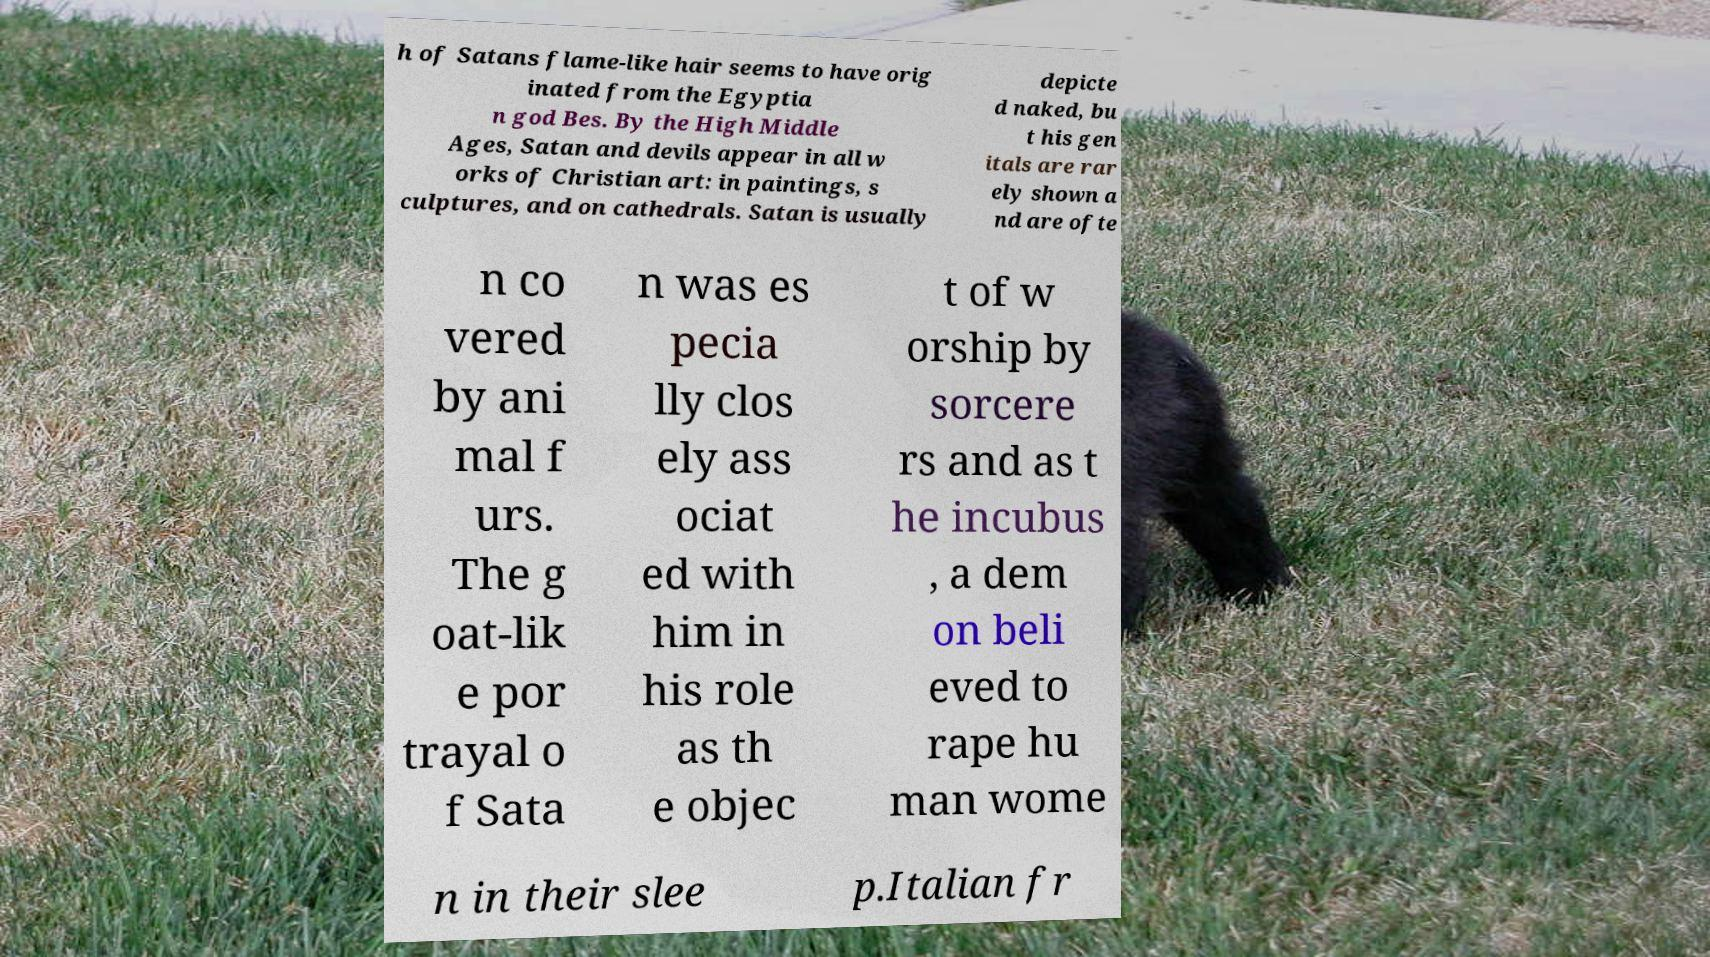There's text embedded in this image that I need extracted. Can you transcribe it verbatim? h of Satans flame-like hair seems to have orig inated from the Egyptia n god Bes. By the High Middle Ages, Satan and devils appear in all w orks of Christian art: in paintings, s culptures, and on cathedrals. Satan is usually depicte d naked, bu t his gen itals are rar ely shown a nd are ofte n co vered by ani mal f urs. The g oat-lik e por trayal o f Sata n was es pecia lly clos ely ass ociat ed with him in his role as th e objec t of w orship by sorcere rs and as t he incubus , a dem on beli eved to rape hu man wome n in their slee p.Italian fr 